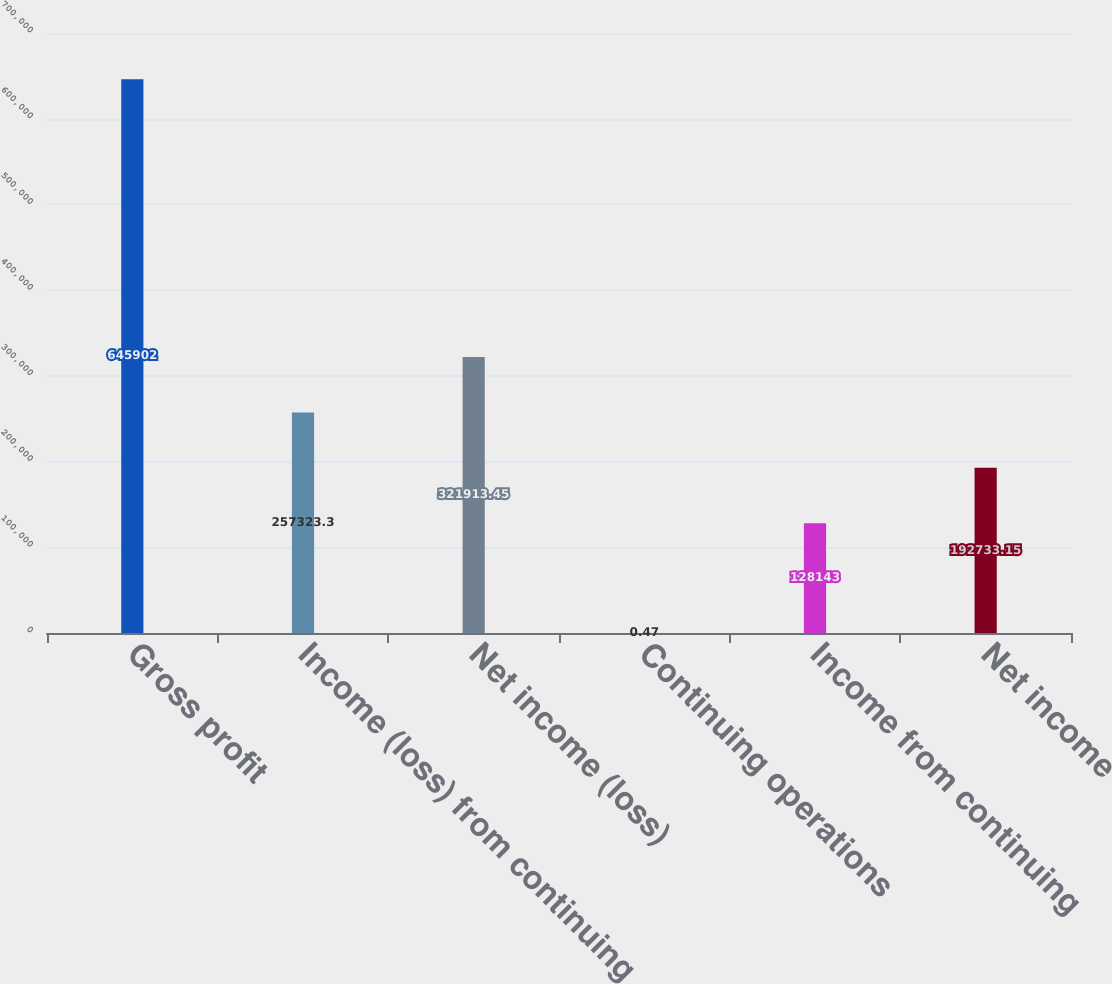Convert chart. <chart><loc_0><loc_0><loc_500><loc_500><bar_chart><fcel>Gross profit<fcel>Income (loss) from continuing<fcel>Net income (loss)<fcel>Continuing operations<fcel>Income from continuing<fcel>Net income<nl><fcel>645902<fcel>257323<fcel>321913<fcel>0.47<fcel>128143<fcel>192733<nl></chart> 